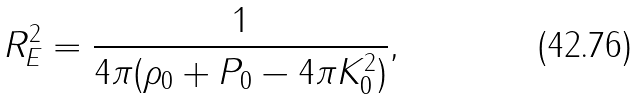<formula> <loc_0><loc_0><loc_500><loc_500>R _ { E } ^ { 2 } = \frac { 1 } { 4 \pi ( \rho _ { 0 } + P _ { 0 } - 4 \pi K _ { 0 } ^ { 2 } ) } ,</formula> 